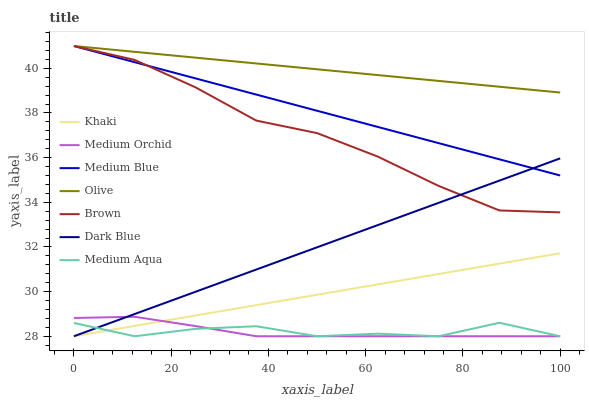Does Medium Orchid have the minimum area under the curve?
Answer yes or no. Yes. Does Olive have the maximum area under the curve?
Answer yes or no. Yes. Does Khaki have the minimum area under the curve?
Answer yes or no. No. Does Khaki have the maximum area under the curve?
Answer yes or no. No. Is Dark Blue the smoothest?
Answer yes or no. Yes. Is Medium Aqua the roughest?
Answer yes or no. Yes. Is Khaki the smoothest?
Answer yes or no. No. Is Khaki the roughest?
Answer yes or no. No. Does Khaki have the lowest value?
Answer yes or no. Yes. Does Medium Blue have the lowest value?
Answer yes or no. No. Does Olive have the highest value?
Answer yes or no. Yes. Does Khaki have the highest value?
Answer yes or no. No. Is Khaki less than Olive?
Answer yes or no. Yes. Is Medium Blue greater than Khaki?
Answer yes or no. Yes. Does Dark Blue intersect Medium Aqua?
Answer yes or no. Yes. Is Dark Blue less than Medium Aqua?
Answer yes or no. No. Is Dark Blue greater than Medium Aqua?
Answer yes or no. No. Does Khaki intersect Olive?
Answer yes or no. No. 